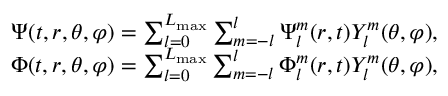<formula> <loc_0><loc_0><loc_500><loc_500>\begin{array} { r } { \Psi ( t , r , \theta , \varphi ) = \sum _ { l = 0 } ^ { L _ { \max } } \sum _ { m = - l } ^ { l } { \Psi _ { l } ^ { m } ( r , t ) Y _ { l } ^ { m } ( \theta , \varphi ) } , } \\ { \Phi ( t , r , \theta , \varphi ) = \sum _ { l = 0 } ^ { L _ { \max } } \sum _ { m = - l } ^ { l } { \Phi _ { l } ^ { m } ( r , t ) Y _ { l } ^ { m } ( \theta , \varphi ) } , } \end{array}</formula> 